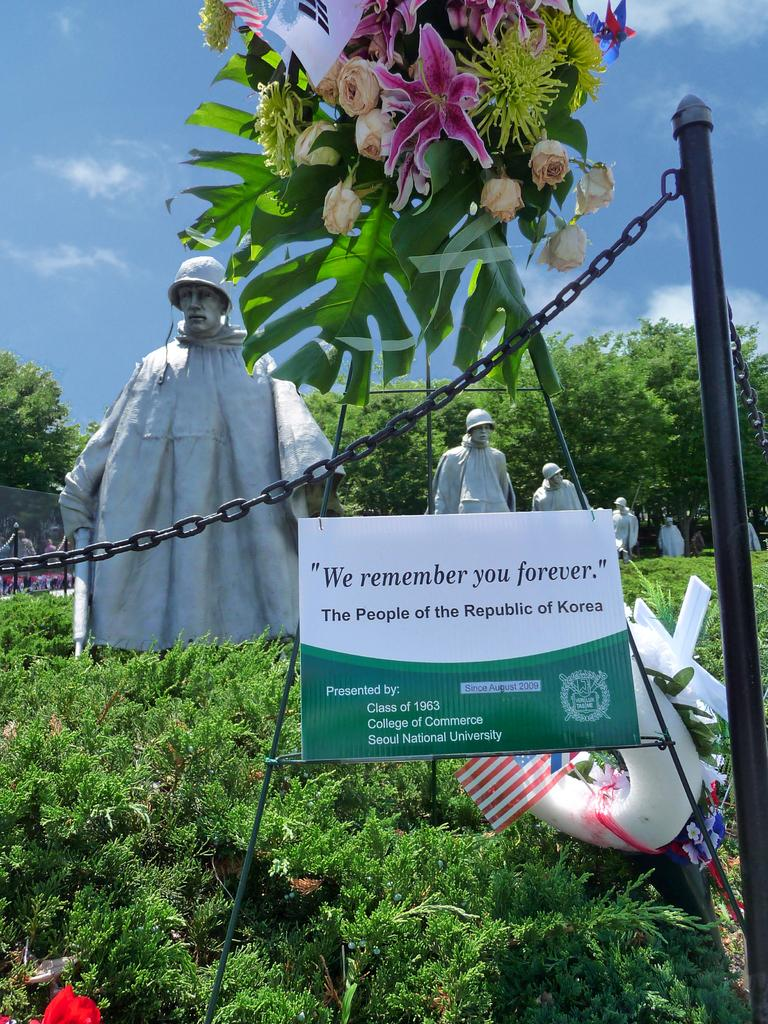What is the main subject of the image? There are many statues of a soldier in the image. What can be seen at the top of the image? There are flowers and leaves at the top of the image. What is the background of the image? The background of the image is the sky. What type of fowl can be seen perched on the soldier's statue in the image? There are no fowl present in the image; it only features statues of a soldier, flowers, leaves, and the sky. What material is the soldier's statue made of in the image? The provided facts do not mention the material of the soldier's statues, so it cannot be determined from the image. 